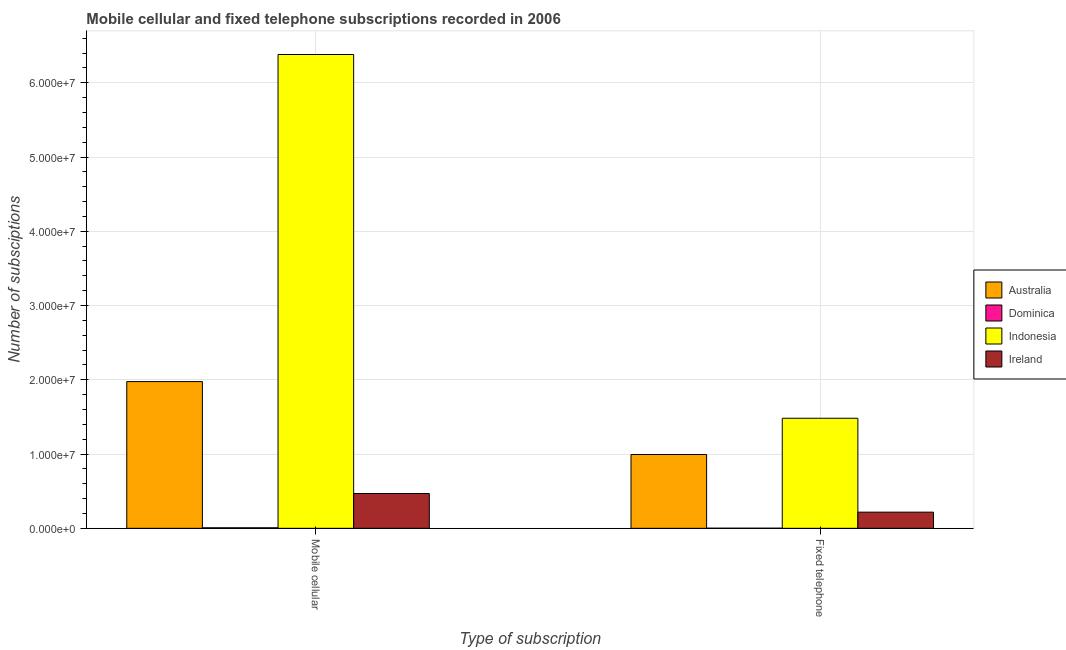How many different coloured bars are there?
Your answer should be compact. 4. How many bars are there on the 2nd tick from the left?
Provide a short and direct response. 4. What is the label of the 2nd group of bars from the left?
Give a very brief answer. Fixed telephone. What is the number of mobile cellular subscriptions in Indonesia?
Provide a short and direct response. 6.38e+07. Across all countries, what is the maximum number of mobile cellular subscriptions?
Your response must be concise. 6.38e+07. Across all countries, what is the minimum number of mobile cellular subscriptions?
Offer a very short reply. 7.15e+04. In which country was the number of fixed telephone subscriptions minimum?
Offer a very short reply. Dominica. What is the total number of mobile cellular subscriptions in the graph?
Your answer should be compact. 8.83e+07. What is the difference between the number of fixed telephone subscriptions in Ireland and that in Dominica?
Provide a short and direct response. 2.16e+06. What is the difference between the number of fixed telephone subscriptions in Australia and the number of mobile cellular subscriptions in Ireland?
Make the answer very short. 5.25e+06. What is the average number of mobile cellular subscriptions per country?
Make the answer very short. 2.21e+07. What is the difference between the number of fixed telephone subscriptions and number of mobile cellular subscriptions in Indonesia?
Give a very brief answer. -4.90e+07. What is the ratio of the number of mobile cellular subscriptions in Australia to that in Ireland?
Keep it short and to the point. 4.21. In how many countries, is the number of mobile cellular subscriptions greater than the average number of mobile cellular subscriptions taken over all countries?
Offer a terse response. 1. What does the 2nd bar from the left in Mobile cellular represents?
Offer a very short reply. Dominica. How many countries are there in the graph?
Your answer should be compact. 4. Does the graph contain any zero values?
Give a very brief answer. No. Does the graph contain grids?
Your answer should be very brief. Yes. How many legend labels are there?
Make the answer very short. 4. What is the title of the graph?
Keep it short and to the point. Mobile cellular and fixed telephone subscriptions recorded in 2006. What is the label or title of the X-axis?
Provide a short and direct response. Type of subscription. What is the label or title of the Y-axis?
Your response must be concise. Number of subsciptions. What is the Number of subsciptions of Australia in Mobile cellular?
Offer a terse response. 1.98e+07. What is the Number of subsciptions in Dominica in Mobile cellular?
Ensure brevity in your answer.  7.15e+04. What is the Number of subsciptions of Indonesia in Mobile cellular?
Keep it short and to the point. 6.38e+07. What is the Number of subsciptions in Ireland in Mobile cellular?
Your response must be concise. 4.69e+06. What is the Number of subsciptions in Australia in Fixed telephone?
Ensure brevity in your answer.  9.94e+06. What is the Number of subsciptions in Dominica in Fixed telephone?
Your response must be concise. 1.75e+04. What is the Number of subsciptions of Indonesia in Fixed telephone?
Ensure brevity in your answer.  1.48e+07. What is the Number of subsciptions in Ireland in Fixed telephone?
Keep it short and to the point. 2.18e+06. Across all Type of subscription, what is the maximum Number of subsciptions of Australia?
Your response must be concise. 1.98e+07. Across all Type of subscription, what is the maximum Number of subsciptions of Dominica?
Provide a short and direct response. 7.15e+04. Across all Type of subscription, what is the maximum Number of subsciptions of Indonesia?
Offer a very short reply. 6.38e+07. Across all Type of subscription, what is the maximum Number of subsciptions of Ireland?
Your answer should be very brief. 4.69e+06. Across all Type of subscription, what is the minimum Number of subsciptions in Australia?
Provide a succinct answer. 9.94e+06. Across all Type of subscription, what is the minimum Number of subsciptions in Dominica?
Keep it short and to the point. 1.75e+04. Across all Type of subscription, what is the minimum Number of subsciptions in Indonesia?
Give a very brief answer. 1.48e+07. Across all Type of subscription, what is the minimum Number of subsciptions of Ireland?
Keep it short and to the point. 2.18e+06. What is the total Number of subsciptions in Australia in the graph?
Give a very brief answer. 2.97e+07. What is the total Number of subsciptions in Dominica in the graph?
Offer a very short reply. 8.90e+04. What is the total Number of subsciptions of Indonesia in the graph?
Provide a short and direct response. 7.86e+07. What is the total Number of subsciptions of Ireland in the graph?
Provide a succinct answer. 6.87e+06. What is the difference between the Number of subsciptions in Australia in Mobile cellular and that in Fixed telephone?
Offer a terse response. 9.82e+06. What is the difference between the Number of subsciptions in Dominica in Mobile cellular and that in Fixed telephone?
Offer a terse response. 5.40e+04. What is the difference between the Number of subsciptions in Indonesia in Mobile cellular and that in Fixed telephone?
Make the answer very short. 4.90e+07. What is the difference between the Number of subsciptions in Ireland in Mobile cellular and that in Fixed telephone?
Make the answer very short. 2.51e+06. What is the difference between the Number of subsciptions in Australia in Mobile cellular and the Number of subsciptions in Dominica in Fixed telephone?
Make the answer very short. 1.97e+07. What is the difference between the Number of subsciptions of Australia in Mobile cellular and the Number of subsciptions of Indonesia in Fixed telephone?
Ensure brevity in your answer.  4.94e+06. What is the difference between the Number of subsciptions in Australia in Mobile cellular and the Number of subsciptions in Ireland in Fixed telephone?
Keep it short and to the point. 1.76e+07. What is the difference between the Number of subsciptions of Dominica in Mobile cellular and the Number of subsciptions of Indonesia in Fixed telephone?
Your answer should be compact. -1.47e+07. What is the difference between the Number of subsciptions in Dominica in Mobile cellular and the Number of subsciptions in Ireland in Fixed telephone?
Your answer should be compact. -2.11e+06. What is the difference between the Number of subsciptions in Indonesia in Mobile cellular and the Number of subsciptions in Ireland in Fixed telephone?
Your answer should be compact. 6.16e+07. What is the average Number of subsciptions in Australia per Type of subscription?
Your response must be concise. 1.48e+07. What is the average Number of subsciptions in Dominica per Type of subscription?
Keep it short and to the point. 4.45e+04. What is the average Number of subsciptions of Indonesia per Type of subscription?
Your response must be concise. 3.93e+07. What is the average Number of subsciptions in Ireland per Type of subscription?
Your answer should be very brief. 3.43e+06. What is the difference between the Number of subsciptions of Australia and Number of subsciptions of Dominica in Mobile cellular?
Offer a terse response. 1.97e+07. What is the difference between the Number of subsciptions of Australia and Number of subsciptions of Indonesia in Mobile cellular?
Give a very brief answer. -4.40e+07. What is the difference between the Number of subsciptions of Australia and Number of subsciptions of Ireland in Mobile cellular?
Give a very brief answer. 1.51e+07. What is the difference between the Number of subsciptions in Dominica and Number of subsciptions in Indonesia in Mobile cellular?
Your response must be concise. -6.37e+07. What is the difference between the Number of subsciptions of Dominica and Number of subsciptions of Ireland in Mobile cellular?
Make the answer very short. -4.62e+06. What is the difference between the Number of subsciptions of Indonesia and Number of subsciptions of Ireland in Mobile cellular?
Provide a short and direct response. 5.91e+07. What is the difference between the Number of subsciptions of Australia and Number of subsciptions of Dominica in Fixed telephone?
Ensure brevity in your answer.  9.92e+06. What is the difference between the Number of subsciptions of Australia and Number of subsciptions of Indonesia in Fixed telephone?
Give a very brief answer. -4.88e+06. What is the difference between the Number of subsciptions in Australia and Number of subsciptions in Ireland in Fixed telephone?
Ensure brevity in your answer.  7.76e+06. What is the difference between the Number of subsciptions of Dominica and Number of subsciptions of Indonesia in Fixed telephone?
Give a very brief answer. -1.48e+07. What is the difference between the Number of subsciptions in Dominica and Number of subsciptions in Ireland in Fixed telephone?
Offer a very short reply. -2.16e+06. What is the difference between the Number of subsciptions in Indonesia and Number of subsciptions in Ireland in Fixed telephone?
Give a very brief answer. 1.26e+07. What is the ratio of the Number of subsciptions of Australia in Mobile cellular to that in Fixed telephone?
Your response must be concise. 1.99. What is the ratio of the Number of subsciptions in Dominica in Mobile cellular to that in Fixed telephone?
Make the answer very short. 4.09. What is the ratio of the Number of subsciptions in Indonesia in Mobile cellular to that in Fixed telephone?
Your answer should be very brief. 4.3. What is the ratio of the Number of subsciptions of Ireland in Mobile cellular to that in Fixed telephone?
Ensure brevity in your answer.  2.15. What is the difference between the highest and the second highest Number of subsciptions in Australia?
Offer a terse response. 9.82e+06. What is the difference between the highest and the second highest Number of subsciptions of Dominica?
Keep it short and to the point. 5.40e+04. What is the difference between the highest and the second highest Number of subsciptions in Indonesia?
Your answer should be very brief. 4.90e+07. What is the difference between the highest and the second highest Number of subsciptions in Ireland?
Your response must be concise. 2.51e+06. What is the difference between the highest and the lowest Number of subsciptions in Australia?
Make the answer very short. 9.82e+06. What is the difference between the highest and the lowest Number of subsciptions in Dominica?
Provide a succinct answer. 5.40e+04. What is the difference between the highest and the lowest Number of subsciptions in Indonesia?
Your response must be concise. 4.90e+07. What is the difference between the highest and the lowest Number of subsciptions in Ireland?
Provide a succinct answer. 2.51e+06. 